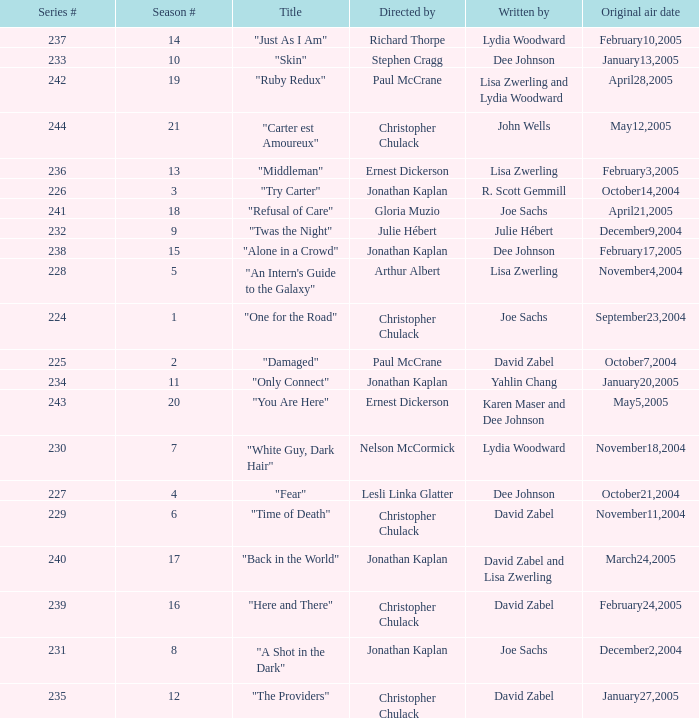Name who directed the episode for the series number 236 Ernest Dickerson. 